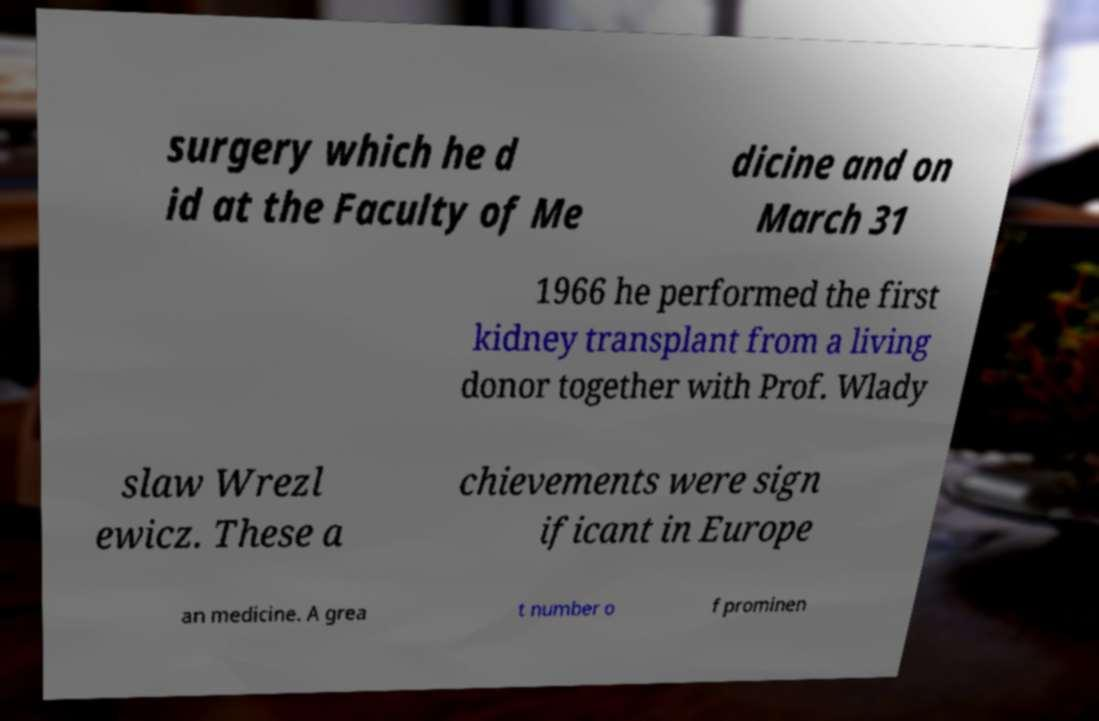For documentation purposes, I need the text within this image transcribed. Could you provide that? surgery which he d id at the Faculty of Me dicine and on March 31 1966 he performed the first kidney transplant from a living donor together with Prof. Wlady slaw Wrezl ewicz. These a chievements were sign ificant in Europe an medicine. A grea t number o f prominen 